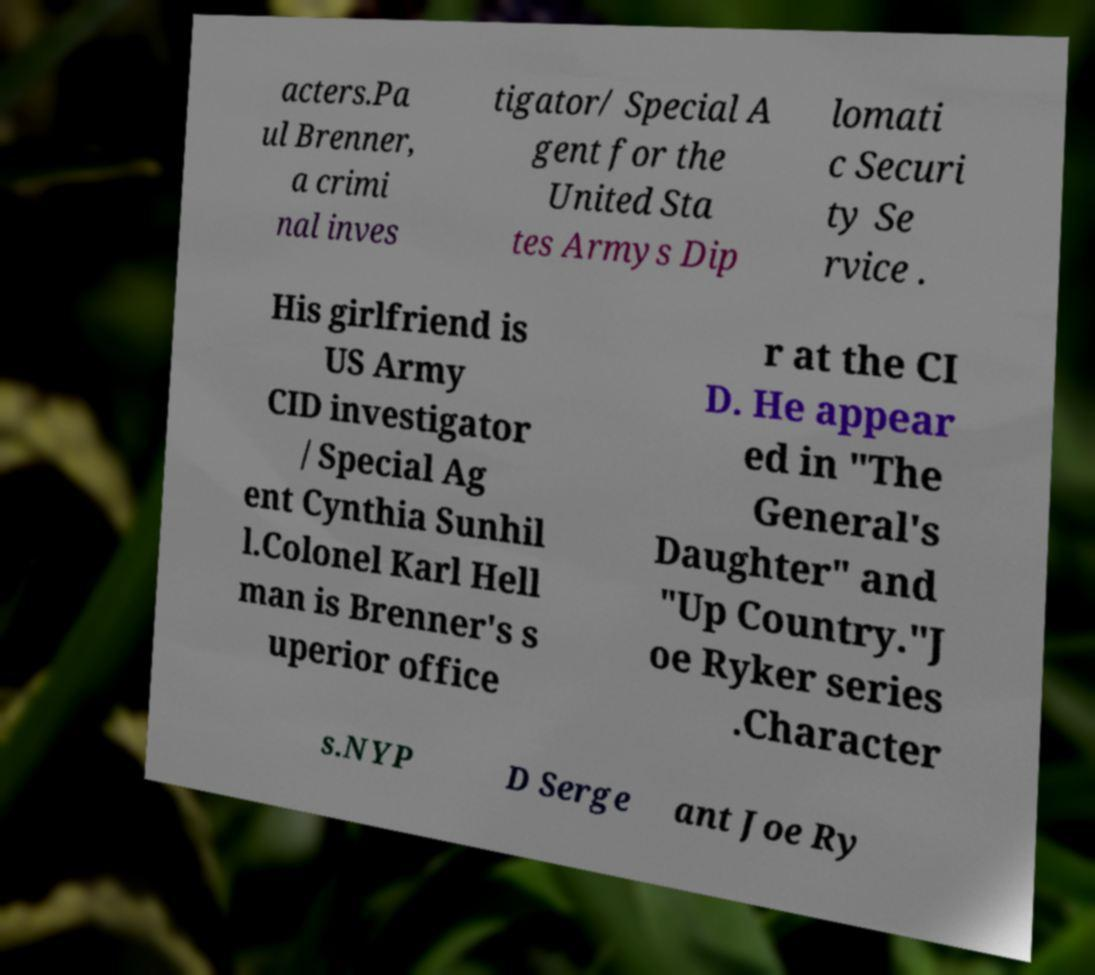Could you extract and type out the text from this image? acters.Pa ul Brenner, a crimi nal inves tigator/ Special A gent for the United Sta tes Armys Dip lomati c Securi ty Se rvice . His girlfriend is US Army CID investigator / Special Ag ent Cynthia Sunhil l.Colonel Karl Hell man is Brenner's s uperior office r at the CI D. He appear ed in "The General's Daughter" and "Up Country."J oe Ryker series .Character s.NYP D Serge ant Joe Ry 